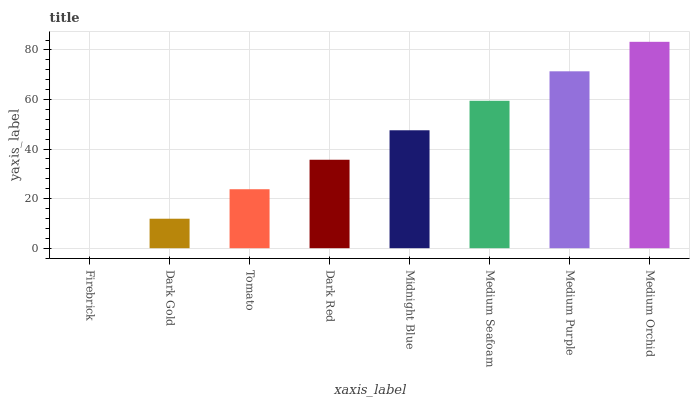Is Firebrick the minimum?
Answer yes or no. Yes. Is Medium Orchid the maximum?
Answer yes or no. Yes. Is Dark Gold the minimum?
Answer yes or no. No. Is Dark Gold the maximum?
Answer yes or no. No. Is Dark Gold greater than Firebrick?
Answer yes or no. Yes. Is Firebrick less than Dark Gold?
Answer yes or no. Yes. Is Firebrick greater than Dark Gold?
Answer yes or no. No. Is Dark Gold less than Firebrick?
Answer yes or no. No. Is Midnight Blue the high median?
Answer yes or no. Yes. Is Dark Red the low median?
Answer yes or no. Yes. Is Medium Purple the high median?
Answer yes or no. No. Is Medium Orchid the low median?
Answer yes or no. No. 